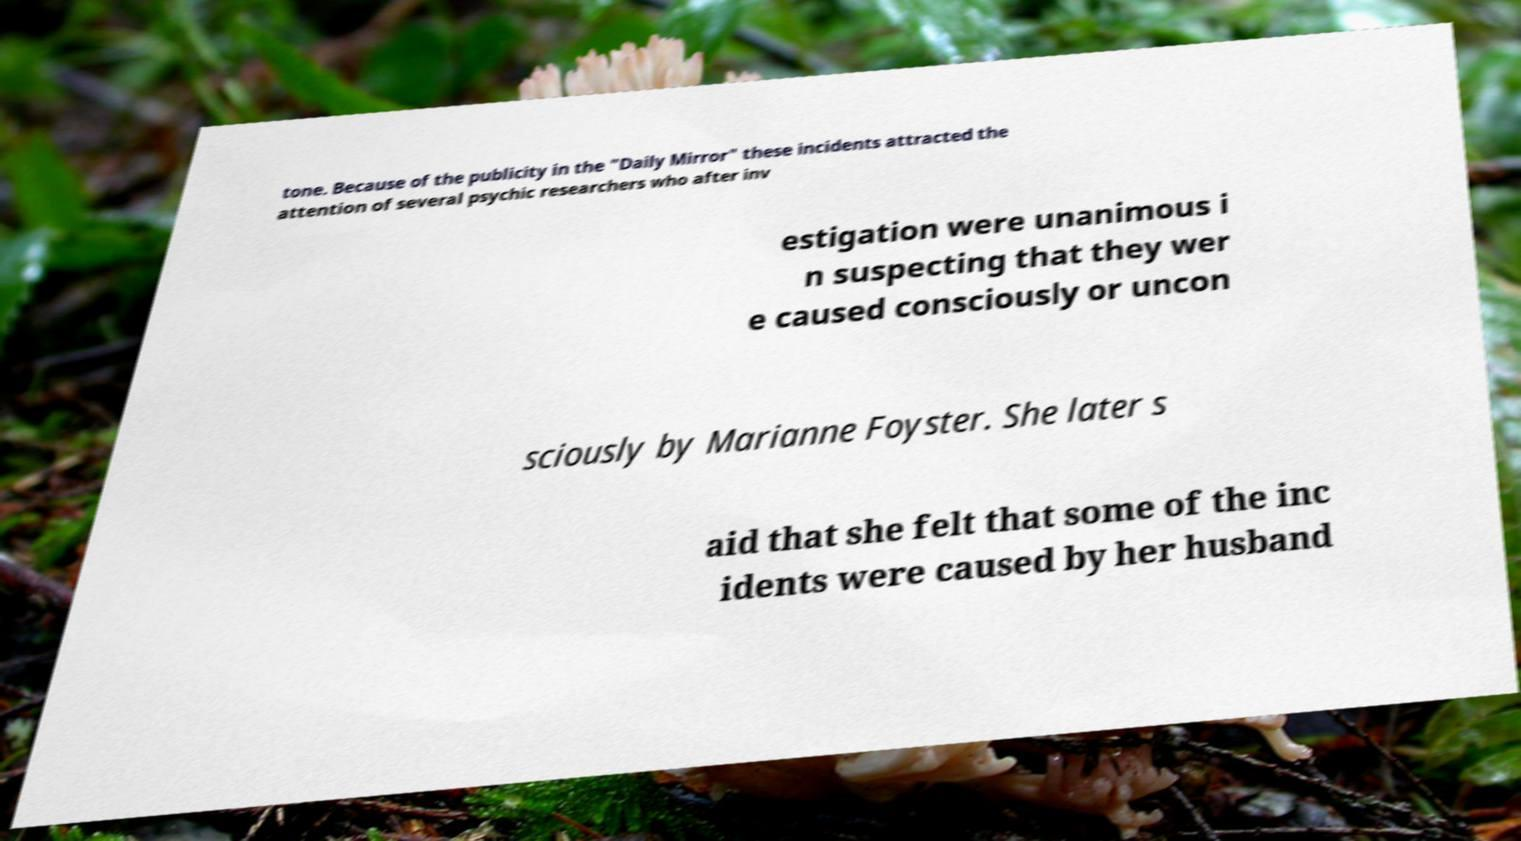Could you assist in decoding the text presented in this image and type it out clearly? tone. Because of the publicity in the "Daily Mirror" these incidents attracted the attention of several psychic researchers who after inv estigation were unanimous i n suspecting that they wer e caused consciously or uncon sciously by Marianne Foyster. She later s aid that she felt that some of the inc idents were caused by her husband 